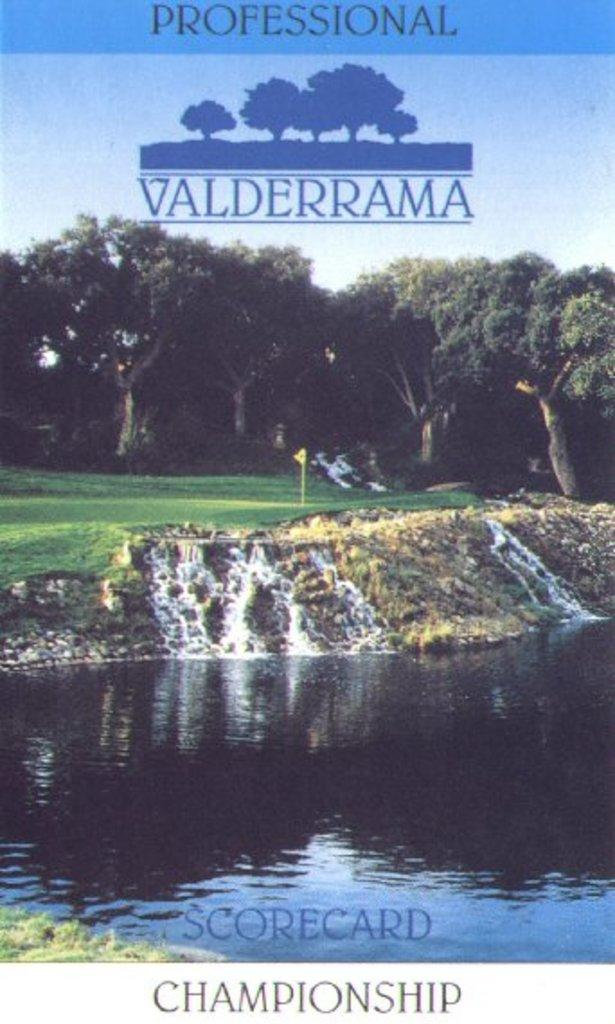<image>
Present a compact description of the photo's key features. A golf course is shown with Professional Valderrama. 